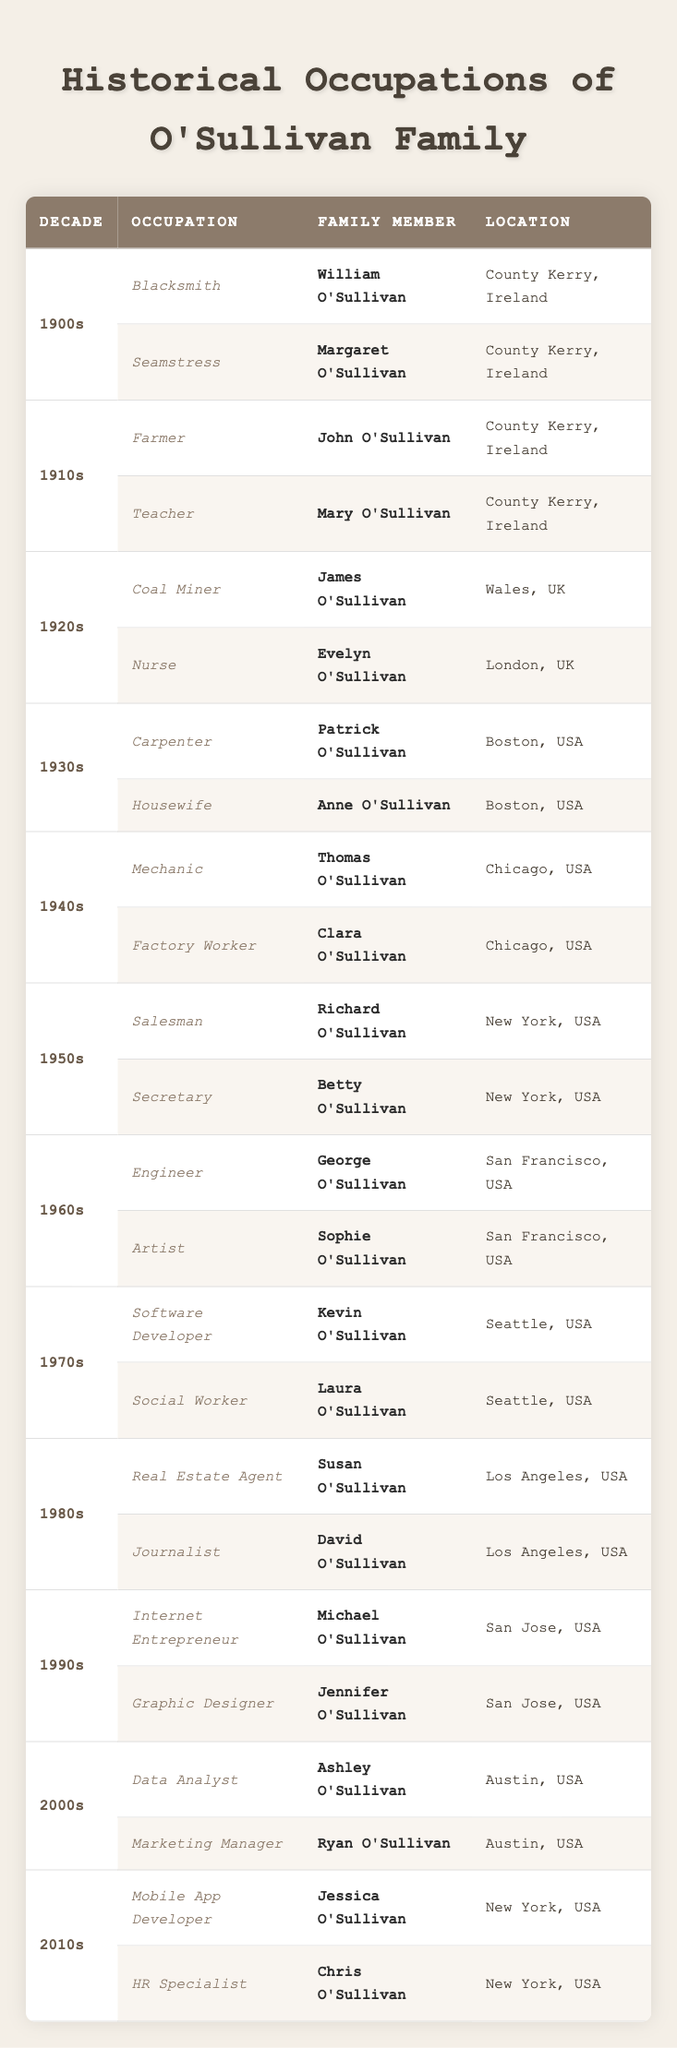What occupations did William O'Sullivan hold in the 1900s? In the 1900s section of the table, William O'Sullivan is listed as a Blacksmith.
Answer: Blacksmith Which family member worked as a Nurse in the 1920s? Referring to the 1920s section of the table, Evelyn O'Sullivan is identified as the Nurse.
Answer: Evelyn O'Sullivan How many family members were documented with occupations in the 1940s? In the 1940s, there are two occupations listed: Mechanic by Thomas O'Sullivan and Factory Worker by Clara O'Sullivan. Therefore, there are two family members.
Answer: 2 Did any family member work as an Engineer in the 1960s? Yes, the table indicates that George O'Sullivan was an Engineer during the 1960s.
Answer: Yes Which decade had a family member as a Mobile App Developer? In the 2010s section, Jessica O'Sullivan is noted as a Mobile App Developer.
Answer: 2010s What was the occupation of Anne O'Sullivan in the 1930s? According to the data from the 1930s, Anne O'Sullivan was a Housewife.
Answer: Housewife Was there a family member who worked in the medical field in the 1980s? No, the occupations listed in the 1980s section are Real Estate Agent and Journalist, which are not in the medical field.
Answer: No Count how many family members worked in the tech industry between the 1990s and 2010s. The 1990s had Michael O'Sullivan as an Internet Entrepreneur, while the 2000s had Ashley O'Sullivan as a Data Analyst, and the 2010s included Jessica O'Sullivan as a Mobile App Developer. There are three family members in total.
Answer: 3 Which decade showed a transition from manual labor jobs to technology-related occupations? Observing the table, the 1940s had manual labor jobs (Mechanic, Factory Worker) and by the 1970s, jobs started to include Technology (Software Developer); this suggests a transition beginning from the 1940s to the 1970s.
Answer: 1940s to 1970s In which locations did Richard and Betty O'Sullivan work during the 1950s? Richard O'Sullivan worked as a Salesman and was located in New York, USA, while Betty O'Sullivan was a Secretary, also located in New York, USA.
Answer: New York, USA 